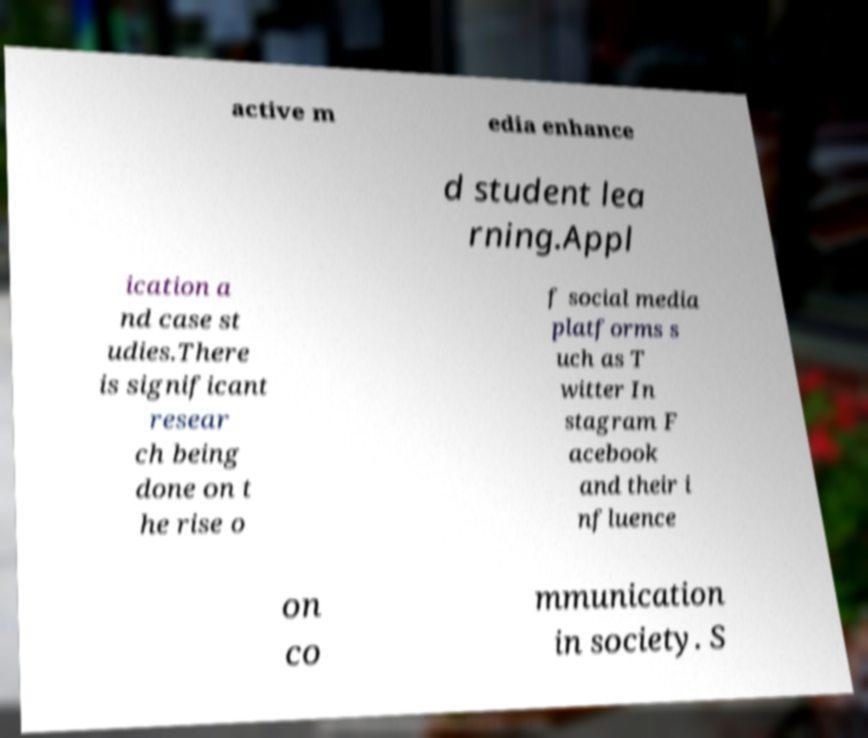Could you assist in decoding the text presented in this image and type it out clearly? active m edia enhance d student lea rning.Appl ication a nd case st udies.There is significant resear ch being done on t he rise o f social media platforms s uch as T witter In stagram F acebook and their i nfluence on co mmunication in society. S 